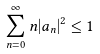<formula> <loc_0><loc_0><loc_500><loc_500>\sum _ { n = 0 } ^ { \infty } n | a _ { n } | ^ { 2 } \leq 1</formula> 